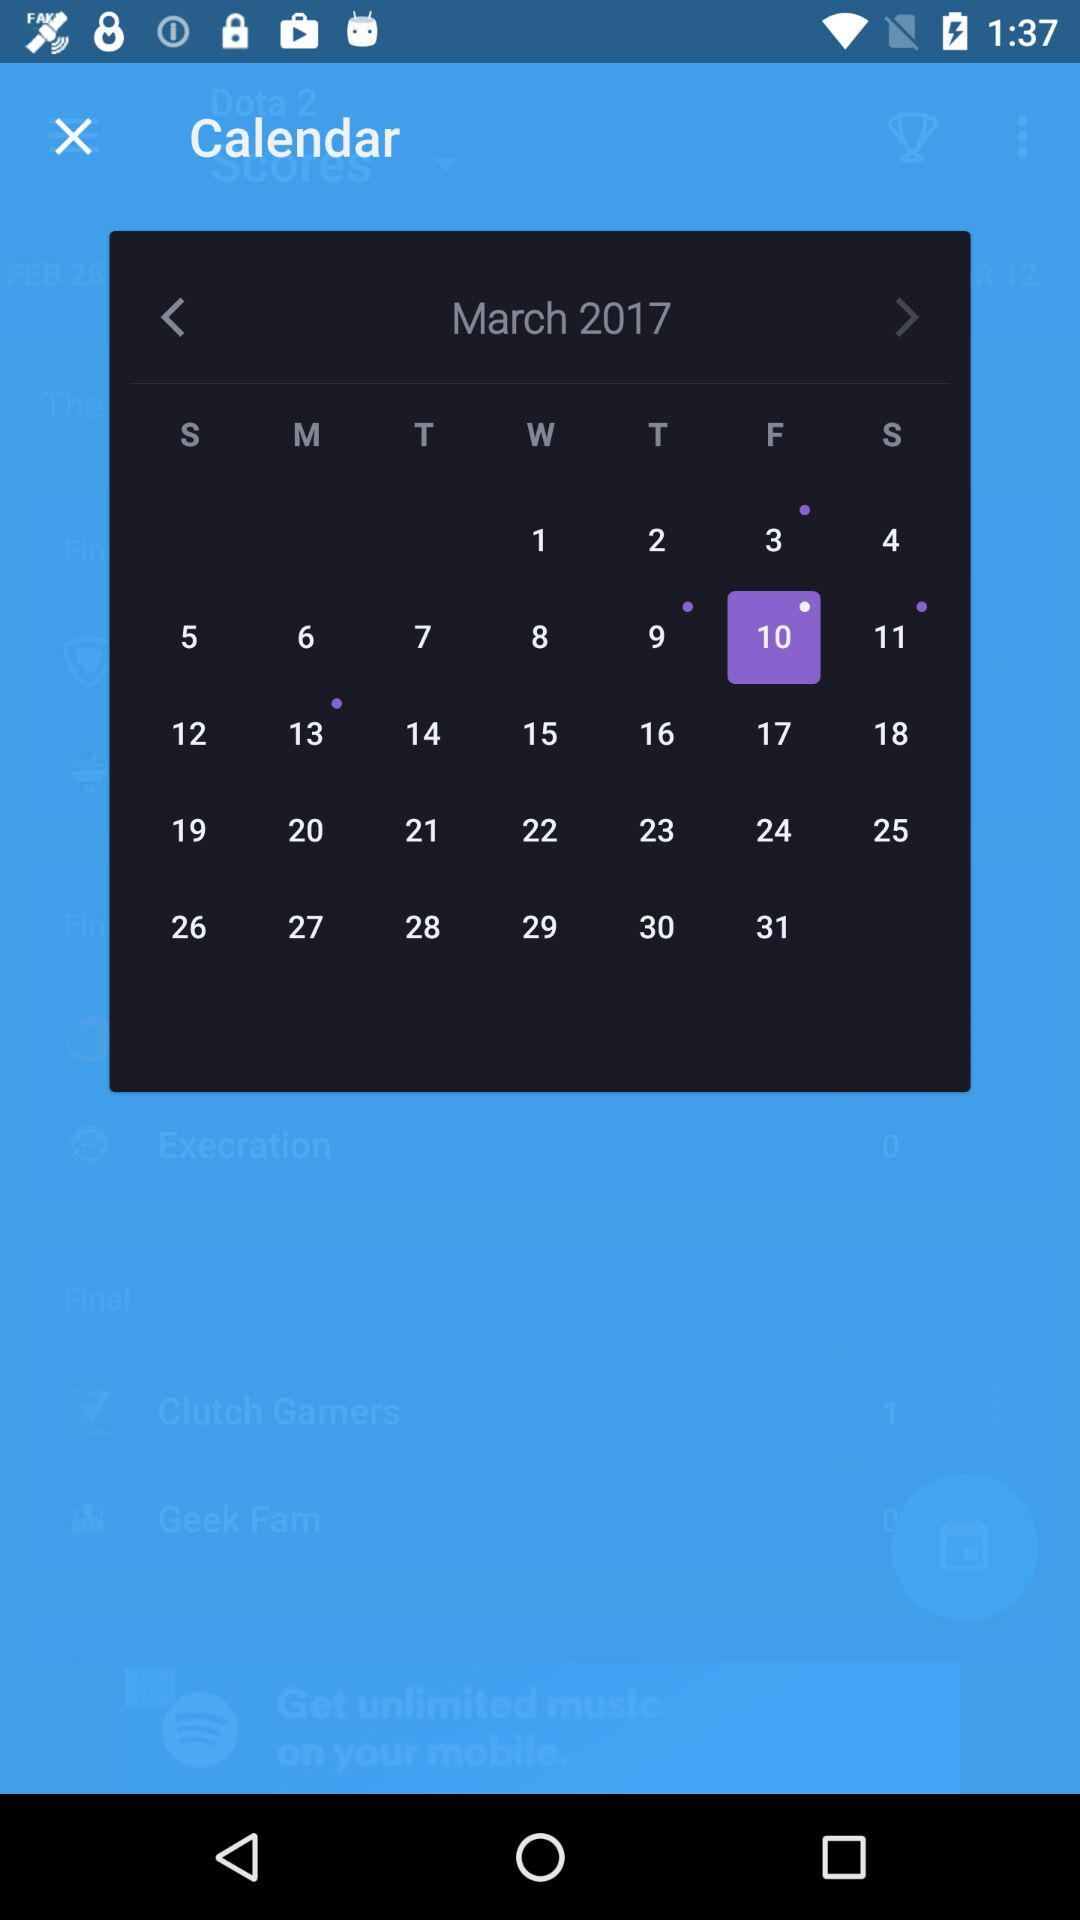Which year is shown on the calendar? The year shown on the calendar is 2017. 